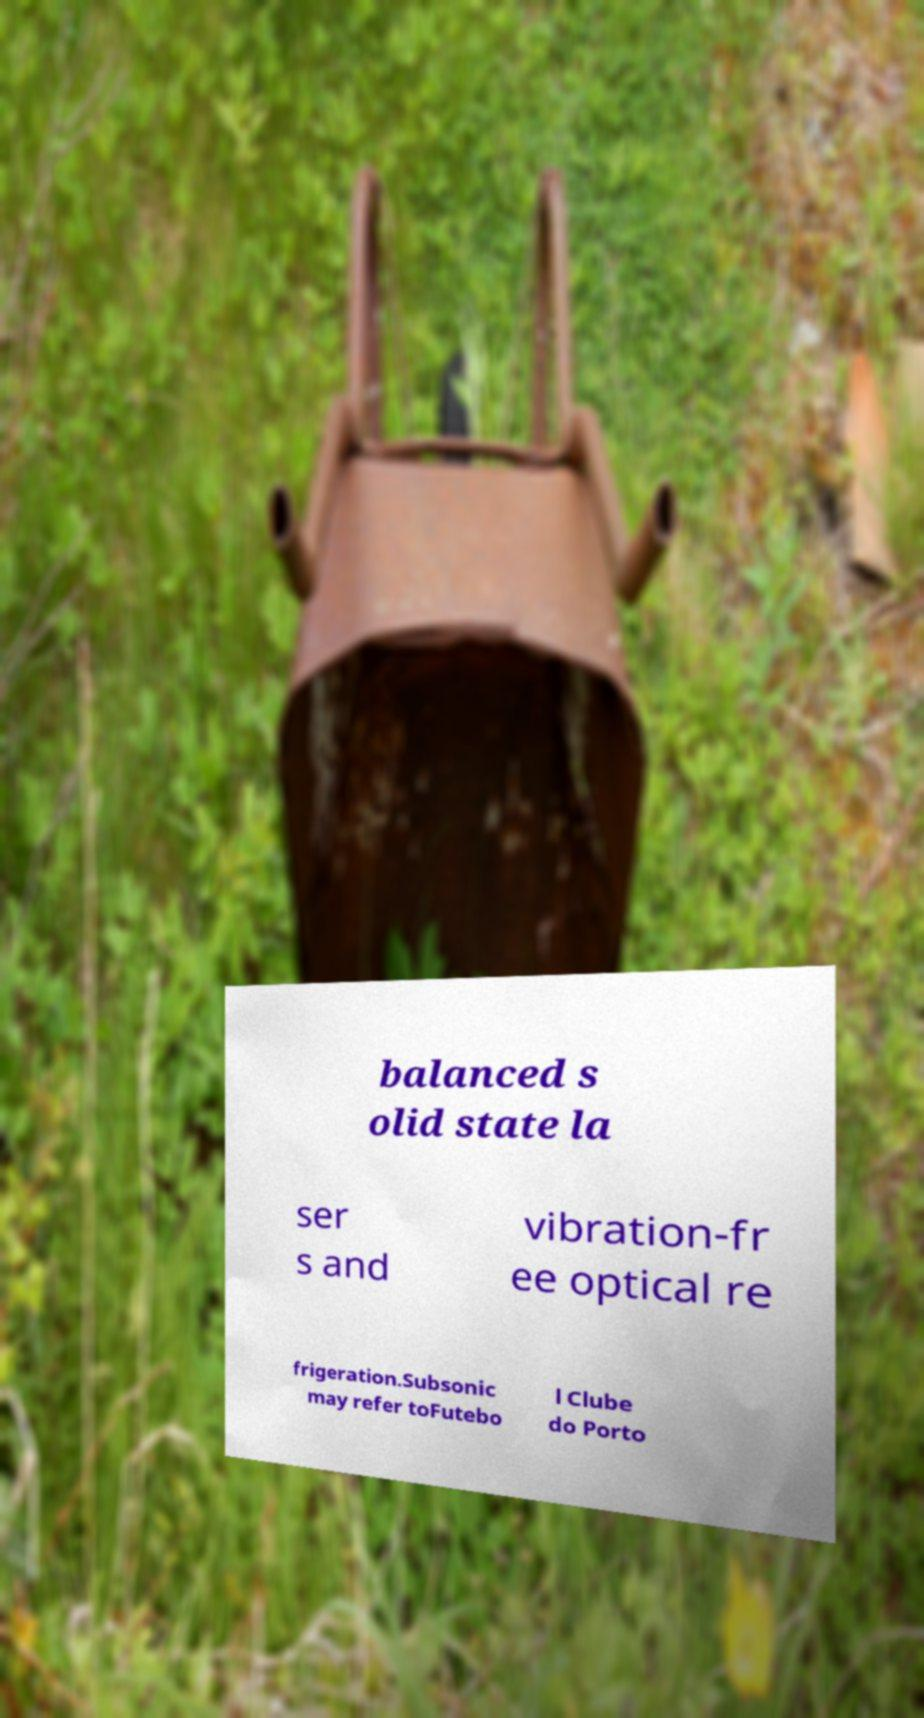There's text embedded in this image that I need extracted. Can you transcribe it verbatim? balanced s olid state la ser s and vibration-fr ee optical re frigeration.Subsonic may refer toFutebo l Clube do Porto 